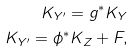Convert formula to latex. <formula><loc_0><loc_0><loc_500><loc_500>K _ { Y ^ { \prime } } = g ^ { \ast } K _ { Y } \\ K _ { Y ^ { \prime } } = \phi ^ { \ast } K _ { Z } + F ,</formula> 